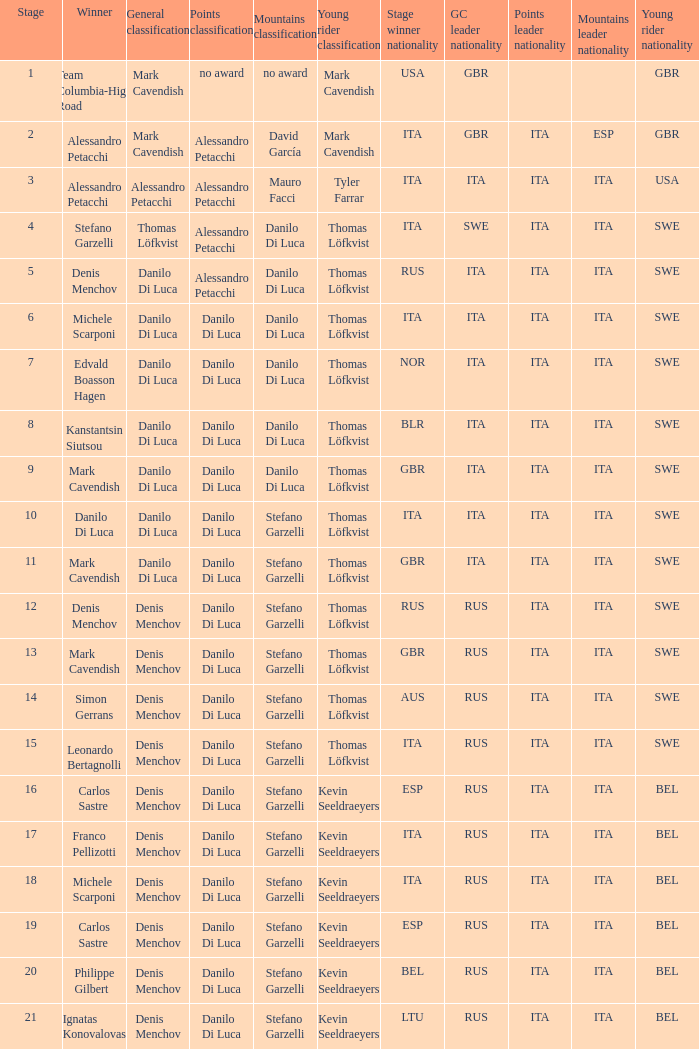When thomas löfkvist is the  young rider classification and alessandro petacchi is the points classification who are the general classifications?  Thomas Löfkvist, Danilo Di Luca. 